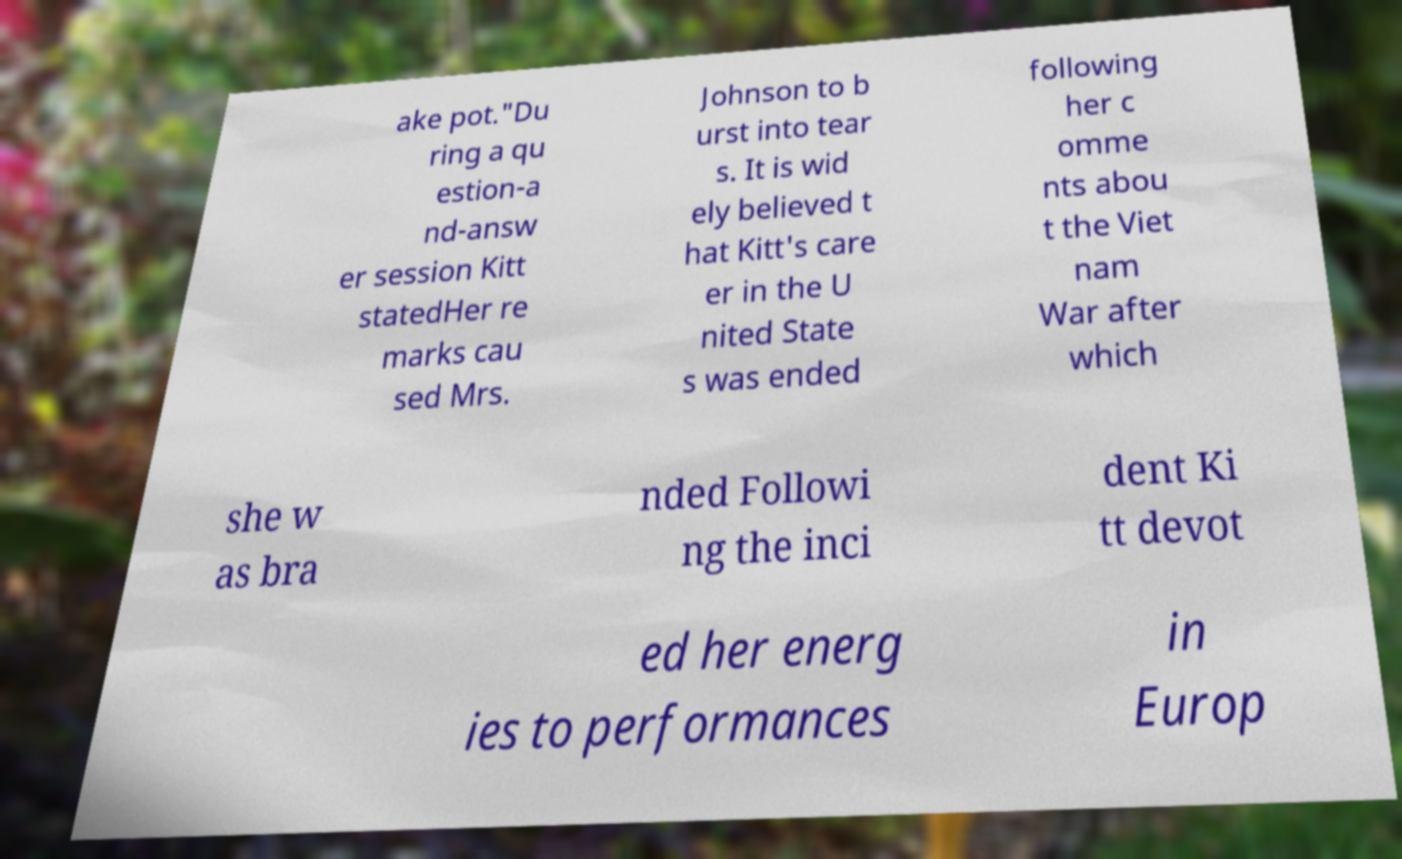I need the written content from this picture converted into text. Can you do that? ake pot."Du ring a qu estion-a nd-answ er session Kitt statedHer re marks cau sed Mrs. Johnson to b urst into tear s. It is wid ely believed t hat Kitt's care er in the U nited State s was ended following her c omme nts abou t the Viet nam War after which she w as bra nded Followi ng the inci dent Ki tt devot ed her energ ies to performances in Europ 